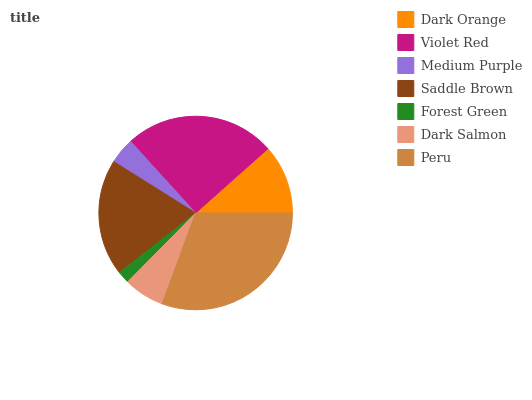Is Forest Green the minimum?
Answer yes or no. Yes. Is Peru the maximum?
Answer yes or no. Yes. Is Violet Red the minimum?
Answer yes or no. No. Is Violet Red the maximum?
Answer yes or no. No. Is Violet Red greater than Dark Orange?
Answer yes or no. Yes. Is Dark Orange less than Violet Red?
Answer yes or no. Yes. Is Dark Orange greater than Violet Red?
Answer yes or no. No. Is Violet Red less than Dark Orange?
Answer yes or no. No. Is Dark Orange the high median?
Answer yes or no. Yes. Is Dark Orange the low median?
Answer yes or no. Yes. Is Saddle Brown the high median?
Answer yes or no. No. Is Violet Red the low median?
Answer yes or no. No. 